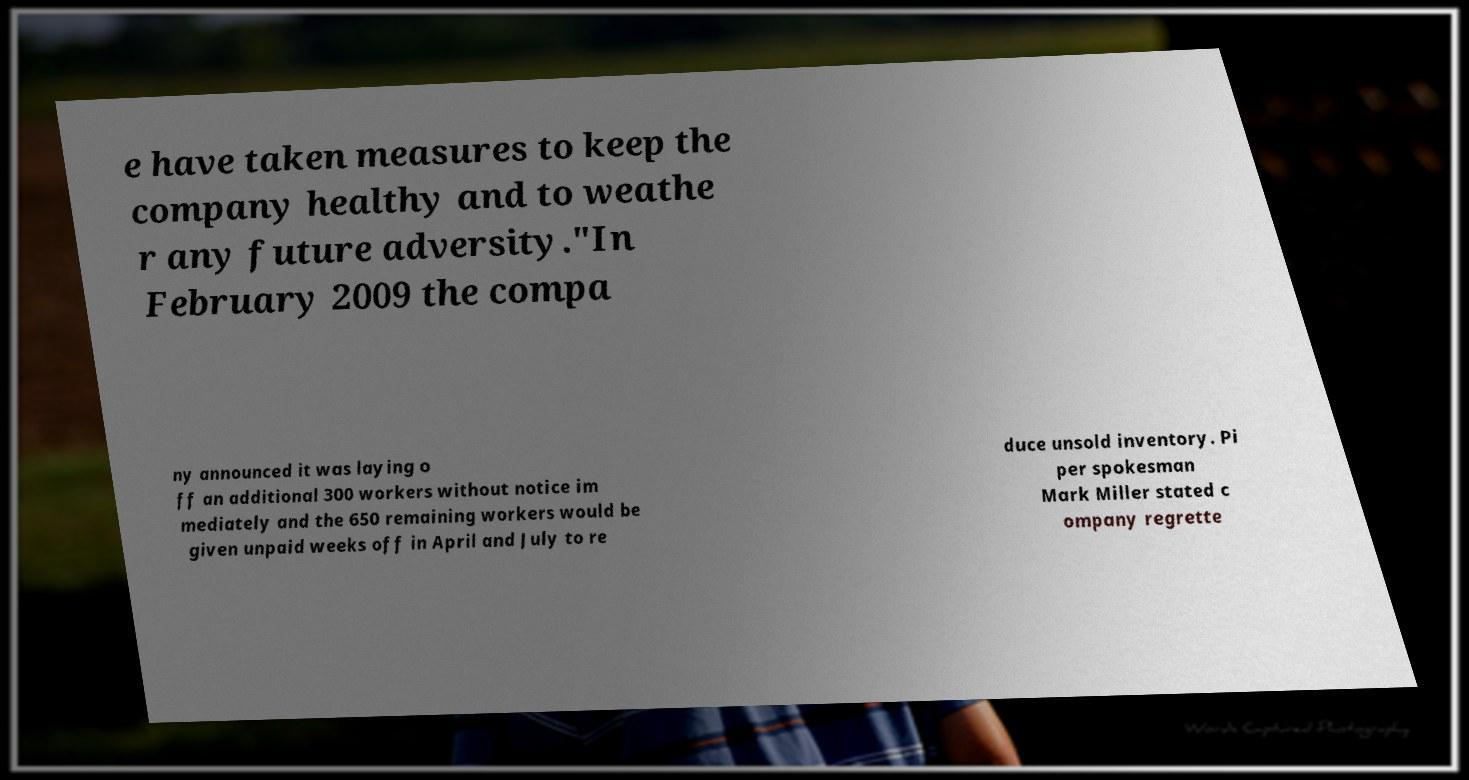Could you assist in decoding the text presented in this image and type it out clearly? e have taken measures to keep the company healthy and to weathe r any future adversity."In February 2009 the compa ny announced it was laying o ff an additional 300 workers without notice im mediately and the 650 remaining workers would be given unpaid weeks off in April and July to re duce unsold inventory. Pi per spokesman Mark Miller stated c ompany regrette 